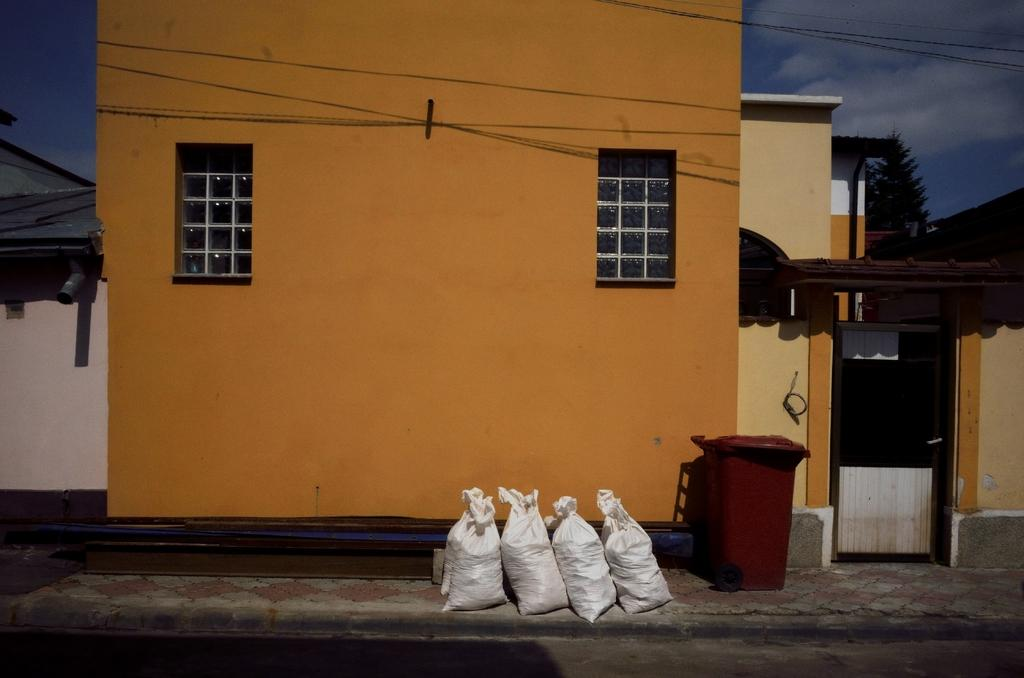What color are the objects in the image? The objects in the image are white. What type of container is present in the image? There is a red container in the image. What structures can be seen in the image? There are buildings in the image. What architectural feature is visible in the image? There are windows in the image. What type of vegetation is present in the image? There is a tree in the image. What man-made structures are visible in the image? There are wires in the image. What natural elements can be seen in the image? There are clouds in the image. What is visible in the background of the image? The sky is visible in the image. What type of fan is being used to protest in the image? There is no fan or protest present in the image. What part of the body is visible in the image? There are no body parts visible in the image. 